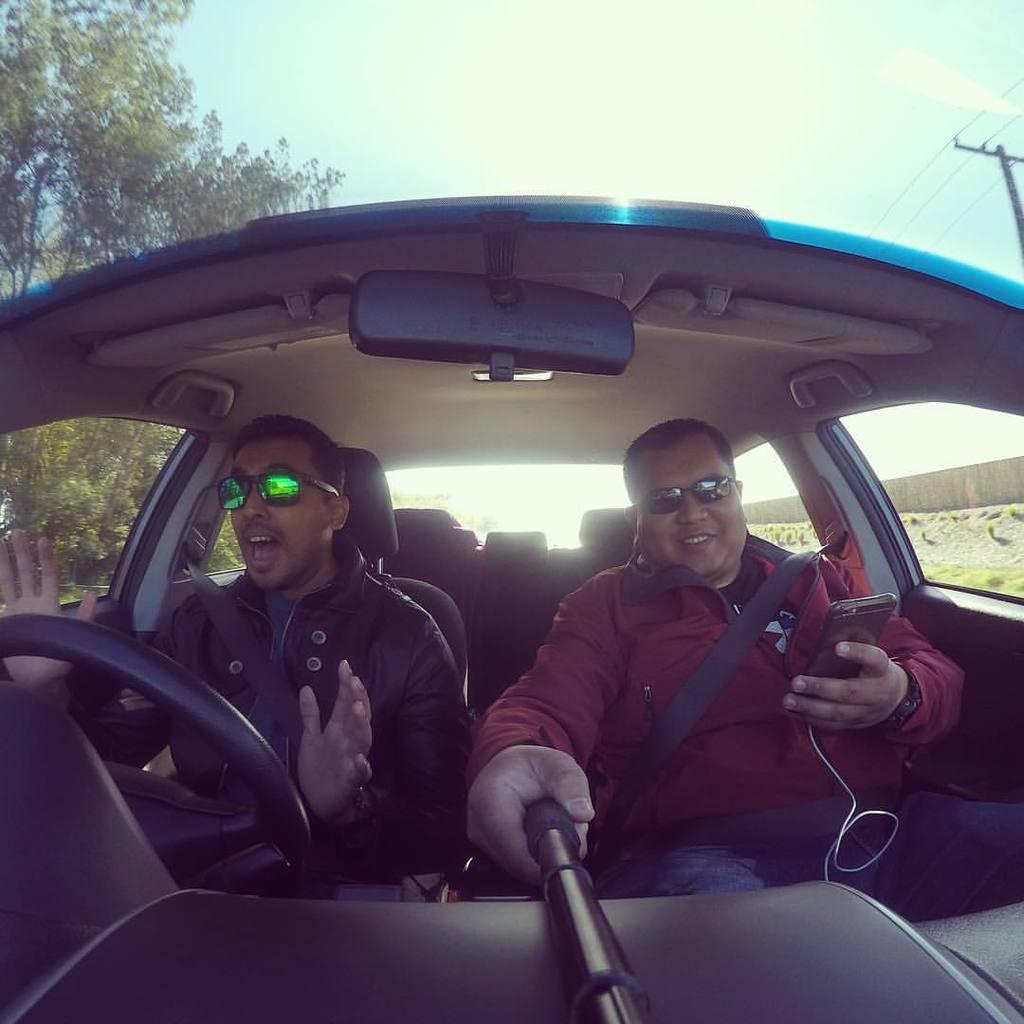How would you summarize this image in a sentence or two? In the picture we can see inside view of the car from the windshield with two men are sitting and wearing the seat belts and one man is holding a selfie stick and mobile phone and from the windows of the car we can see some trees and on the other side we can see the pole with wires and in the background we can see the sky with clouds. 